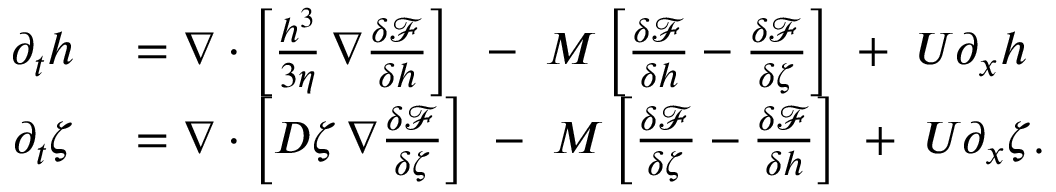Convert formula to latex. <formula><loc_0><loc_0><loc_500><loc_500>\begin{array} { r l } { \partial _ { t } h } & = \nabla \cdot \left [ \frac { h ^ { 3 } } { 3 \eta } \, \nabla \frac { \delta \mathcal { F } } { \delta h } \right ] \ \, - \ M \left [ \frac { \delta \mathcal { F } } { \delta h } - \frac { \delta \mathcal { F } } { \delta \zeta } \right ] \ + \ U \partial _ { x } h } \\ { \partial _ { t } \zeta } & = \nabla \cdot \left [ D \zeta \, \nabla \frac { \delta \mathcal { F } } { \delta \zeta } \right ] \ - \ M \left [ \frac { \delta \mathcal { F } } { \delta \zeta } - \frac { \delta \mathcal { F } } { \delta h } \right ] \ + \ U \partial _ { x } \zeta . } \end{array}</formula> 